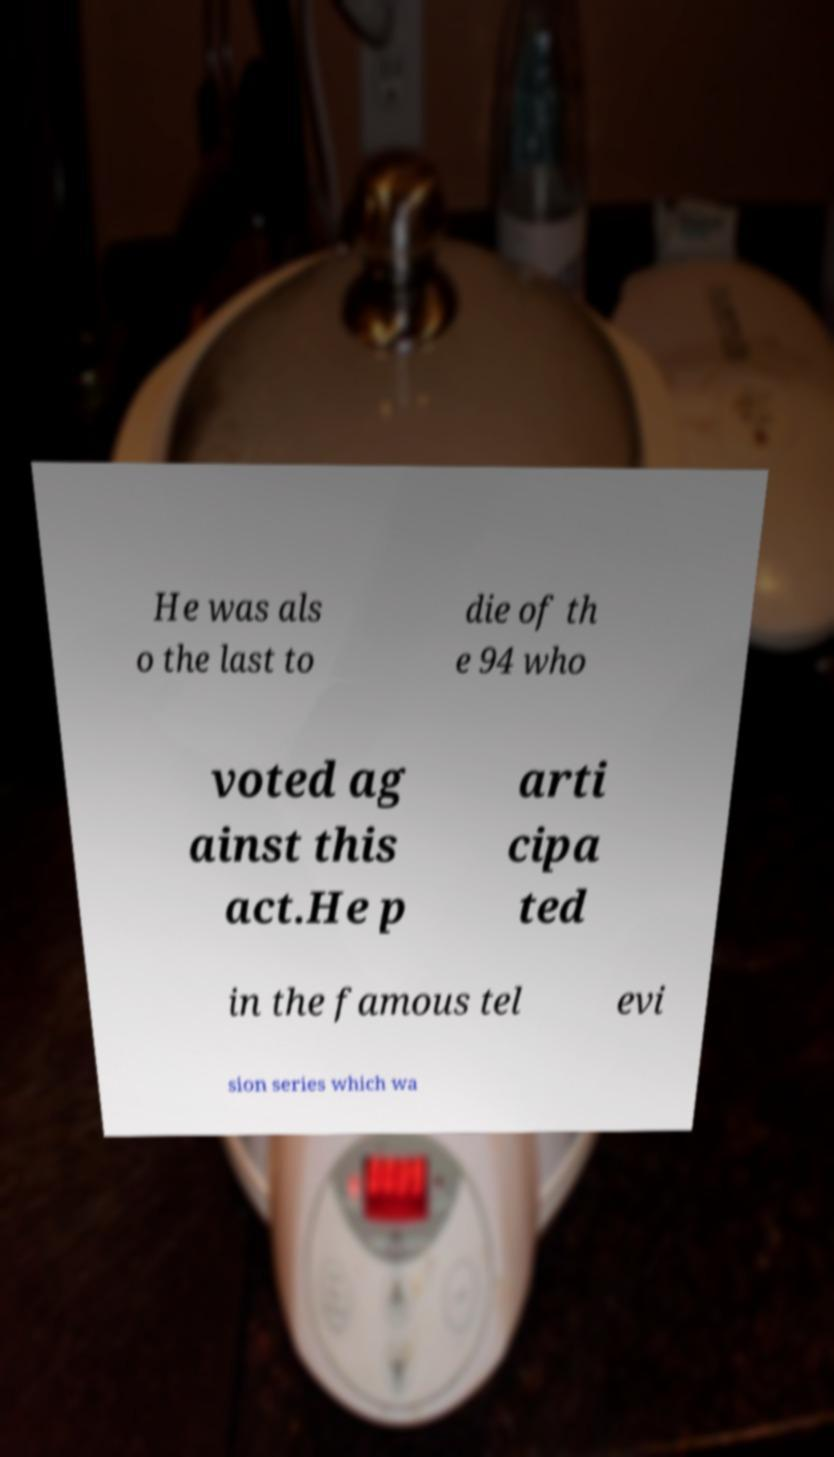Could you assist in decoding the text presented in this image and type it out clearly? He was als o the last to die of th e 94 who voted ag ainst this act.He p arti cipa ted in the famous tel evi sion series which wa 